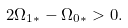Convert formula to latex. <formula><loc_0><loc_0><loc_500><loc_500>2 \Omega _ { 1 * } - \Omega _ { 0 * } > 0 .</formula> 